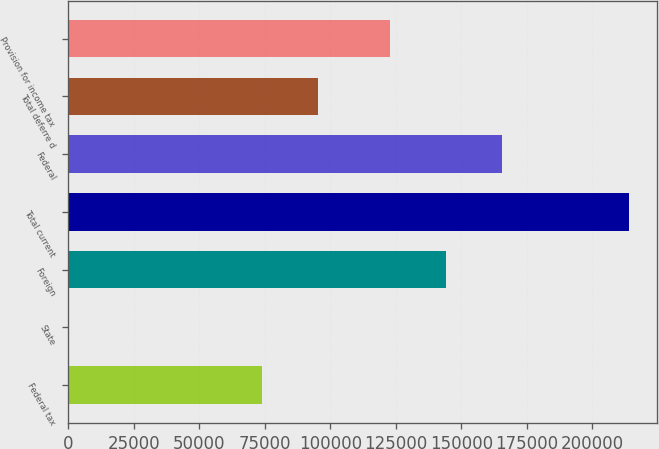Convert chart to OTSL. <chart><loc_0><loc_0><loc_500><loc_500><bar_chart><fcel>Federal tax<fcel>State<fcel>Foreign<fcel>Total current<fcel>Federal<fcel>Total deferre d<fcel>Provision for income tax<nl><fcel>74049<fcel>2<fcel>144114<fcel>213970<fcel>165511<fcel>95445.8<fcel>122717<nl></chart> 